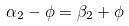Convert formula to latex. <formula><loc_0><loc_0><loc_500><loc_500>\alpha _ { 2 } - \phi = \beta _ { 2 } + \phi</formula> 